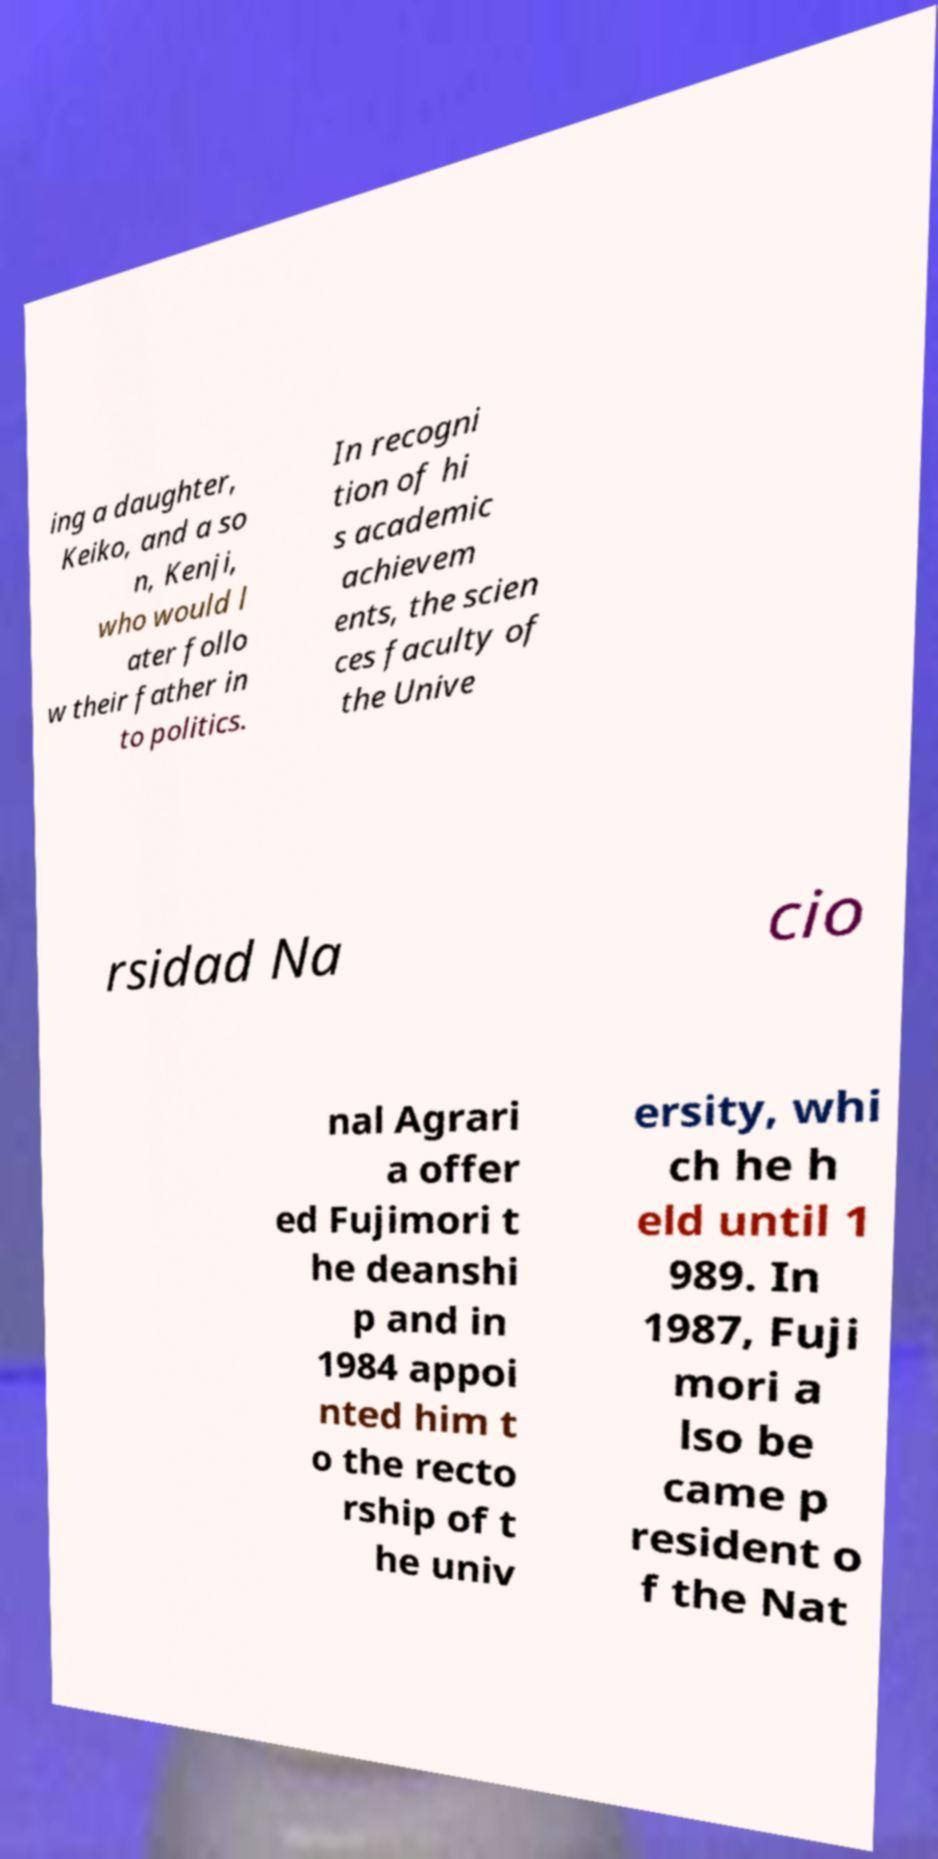What messages or text are displayed in this image? I need them in a readable, typed format. ing a daughter, Keiko, and a so n, Kenji, who would l ater follo w their father in to politics. In recogni tion of hi s academic achievem ents, the scien ces faculty of the Unive rsidad Na cio nal Agrari a offer ed Fujimori t he deanshi p and in 1984 appoi nted him t o the recto rship of t he univ ersity, whi ch he h eld until 1 989. In 1987, Fuji mori a lso be came p resident o f the Nat 